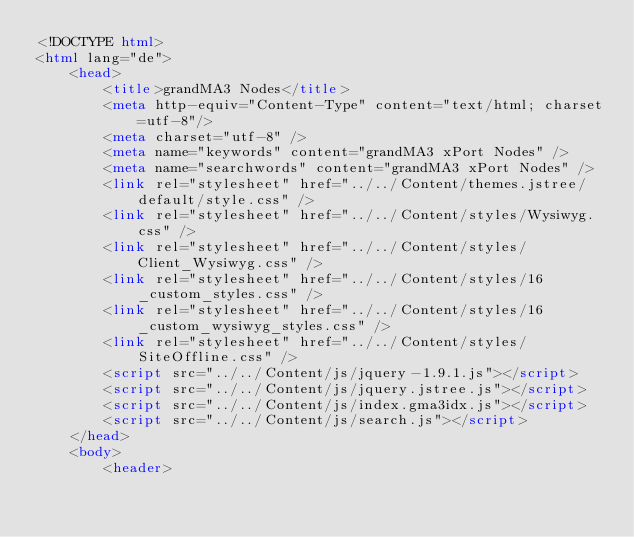Convert code to text. <code><loc_0><loc_0><loc_500><loc_500><_HTML_><!DOCTYPE html>
<html lang="de">
	<head>
		<title>grandMA3 Nodes</title>
		<meta http-equiv="Content-Type" content="text/html; charset=utf-8"/>
		<meta charset="utf-8" />
		<meta name="keywords" content="grandMA3 xPort Nodes" />
		<meta name="searchwords" content="grandMA3 xPort Nodes" />
		<link rel="stylesheet" href="../../Content/themes.jstree/default/style.css" />
		<link rel="stylesheet" href="../../Content/styles/Wysiwyg.css" />
		<link rel="stylesheet" href="../../Content/styles/Client_Wysiwyg.css" />
		<link rel="stylesheet" href="../../Content/styles/16_custom_styles.css" />
		<link rel="stylesheet" href="../../Content/styles/16_custom_wysiwyg_styles.css" />
		<link rel="stylesheet" href="../../Content/styles/SiteOffline.css" />
		<script src="../../Content/js/jquery-1.9.1.js"></script>
		<script src="../../Content/js/jquery.jstree.js"></script>
		<script src="../../Content/js/index.gma3idx.js"></script>
		<script src="../../Content/js/search.js"></script>
	</head>
	<body>
		<header></code> 